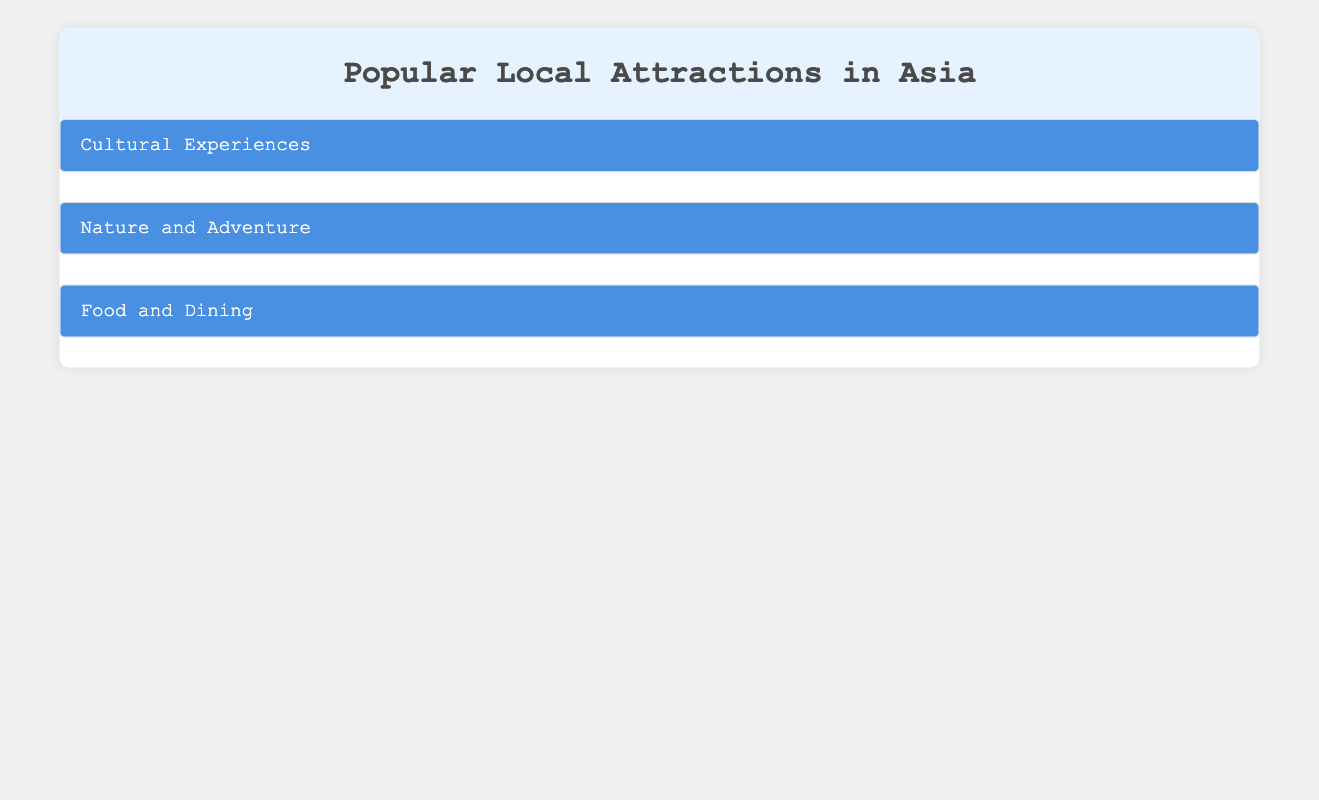What is the location of The Forbidden City? The table states that The Forbidden City is located in Beijing, China, as mentioned under the Historical Sites category of Cultural Experiences.
Answer: Beijing, China How many Historical Sites are listed under Cultural Experiences? There are two Historical Sites listed: The Forbidden City and Wat Phra Kaew. Thus, the total count is 2.
Answer: 2 Is Gardens by the Bay located in Japan? The table shows that Gardens by the Bay is located in Singapore, not Japan. Therefore, the answer is false.
Answer: False What are the names of the two local cuisines listed? The table lists two local cuisines: Street Food Tour in Taipei and Hawker Centres in Singapore, found under the Local Cuisines subcategory.
Answer: Street Food Tour in Taipei, Hawker Centres in Singapore Which category has more attractions, Food and Dining or Cultural Experiences? Food and Dining includes 4 attractions (2 Local Cuisines and 2 Fine Dining), while Cultural Experiences has 4 attractions as well (2 Historical Sites and 2 Museums). Both categories have an equal number of attractions.
Answer: Equal What is the average number of attractions per category? There are a total of 12 attractions (4 in Cultural Experiences, 4 in Nature and Adventure, and 4 in Food and Dining). Dividing this total by the number of categories (3): 12/3 = 4.
Answer: 4 Which attraction has the description mentioning "freely-roaming deer"? The table indicates that Nara Park, located in Nara, Japan, is described as a large park home to over a thousand freely-roaming deer.
Answer: Nara Park How many outdoor activities are listed under Nature and Adventure? Under the Outdoor Activities subcategory, the table lists two activities: Hiking in Jiuzhaigou Valley and Rafting in Pai River, therefore the total count is 2.
Answer: 2 Do any of the listed fine dining restaurants have Michelin stars? The table notes that Mingles in Seoul, South Korea, is a Michelin-starred restaurant, indicating that at least one fine dining restaurant in this category holds that accolade.
Answer: Yes 